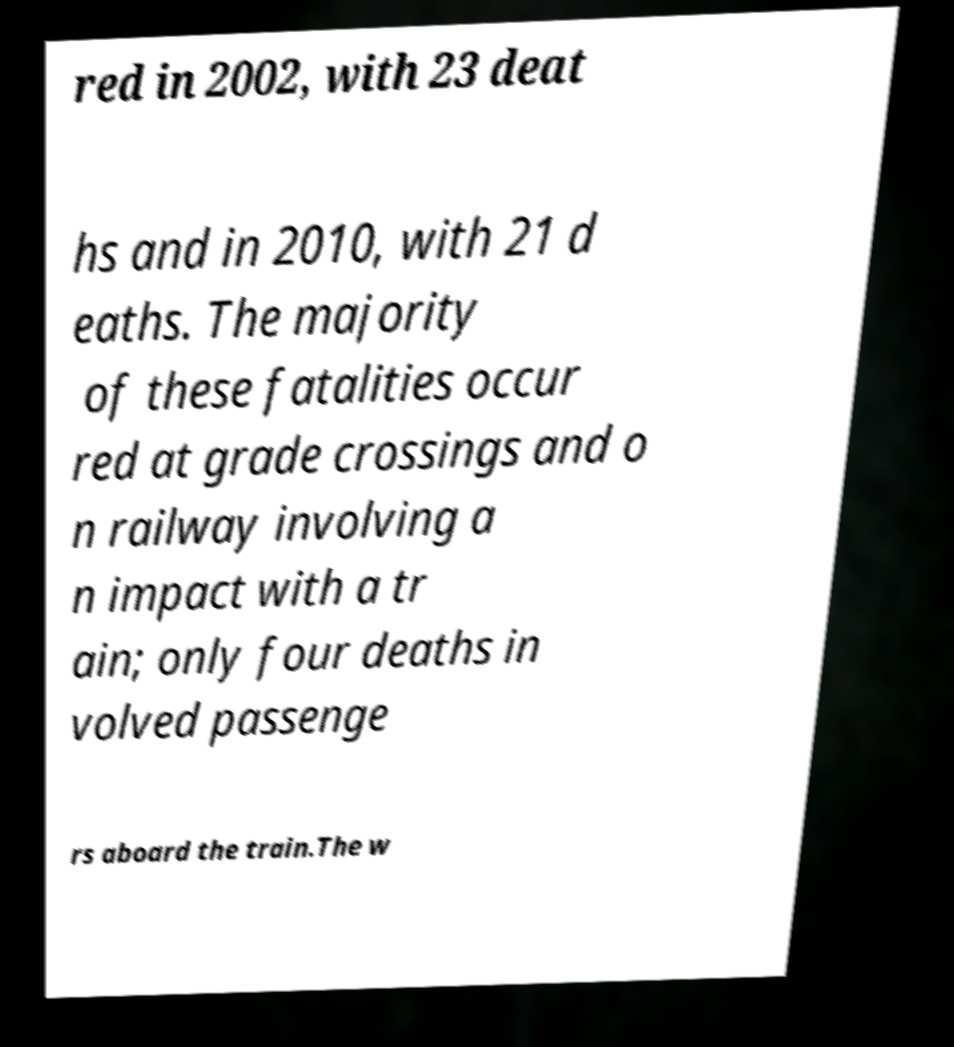What messages or text are displayed in this image? I need them in a readable, typed format. red in 2002, with 23 deat hs and in 2010, with 21 d eaths. The majority of these fatalities occur red at grade crossings and o n railway involving a n impact with a tr ain; only four deaths in volved passenge rs aboard the train.The w 